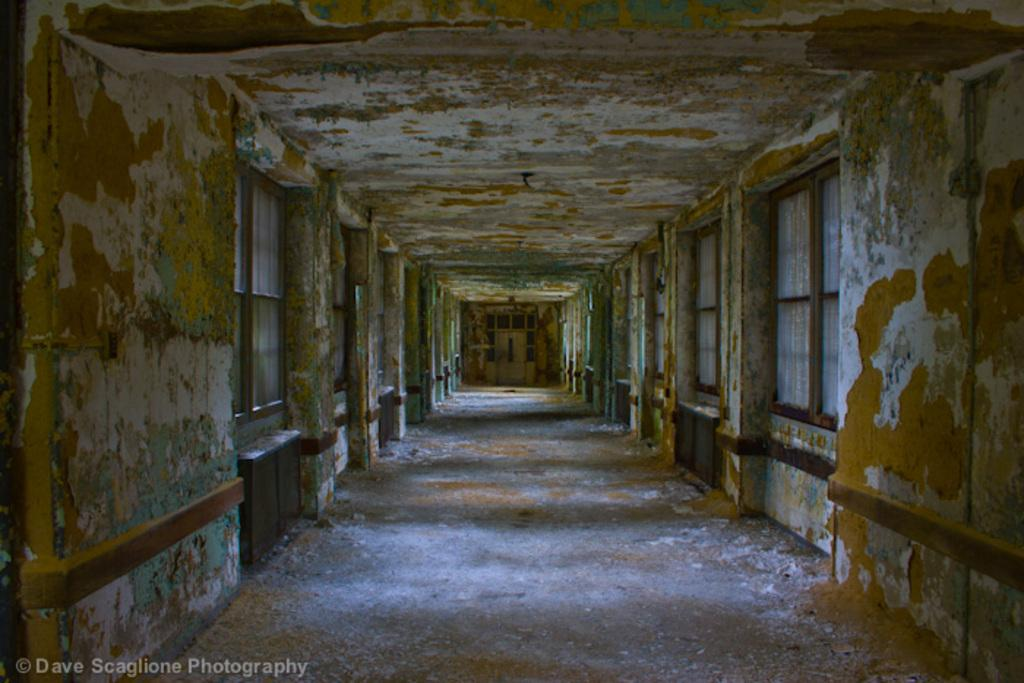What architectural features can be seen in the image? There are windows, walls, and a ceiling visible in the image. What type of location is depicted in the image? The image is an inside view of a building. Is there any text or marking on the image? Yes, there is a watermark on the bottom left side of the image. What type of oatmeal is being served in the image? There is no oatmeal present in the image; it is an inside view of a building with architectural features and a watermark. 